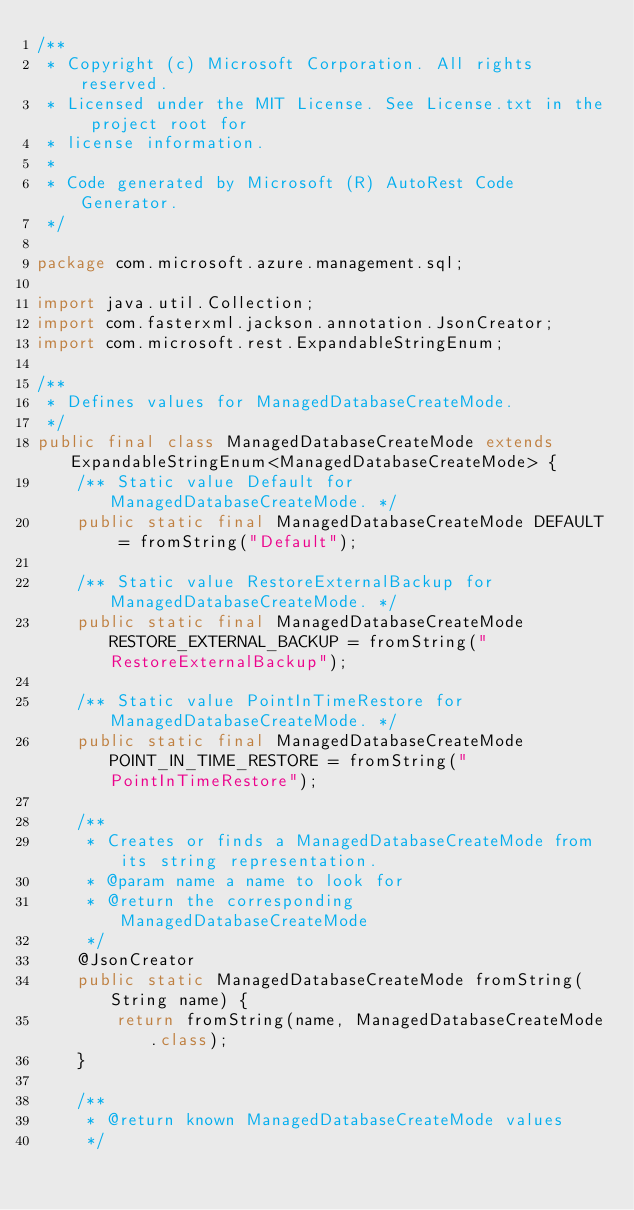Convert code to text. <code><loc_0><loc_0><loc_500><loc_500><_Java_>/**
 * Copyright (c) Microsoft Corporation. All rights reserved.
 * Licensed under the MIT License. See License.txt in the project root for
 * license information.
 *
 * Code generated by Microsoft (R) AutoRest Code Generator.
 */

package com.microsoft.azure.management.sql;

import java.util.Collection;
import com.fasterxml.jackson.annotation.JsonCreator;
import com.microsoft.rest.ExpandableStringEnum;

/**
 * Defines values for ManagedDatabaseCreateMode.
 */
public final class ManagedDatabaseCreateMode extends ExpandableStringEnum<ManagedDatabaseCreateMode> {
    /** Static value Default for ManagedDatabaseCreateMode. */
    public static final ManagedDatabaseCreateMode DEFAULT = fromString("Default");

    /** Static value RestoreExternalBackup for ManagedDatabaseCreateMode. */
    public static final ManagedDatabaseCreateMode RESTORE_EXTERNAL_BACKUP = fromString("RestoreExternalBackup");

    /** Static value PointInTimeRestore for ManagedDatabaseCreateMode. */
    public static final ManagedDatabaseCreateMode POINT_IN_TIME_RESTORE = fromString("PointInTimeRestore");

    /**
     * Creates or finds a ManagedDatabaseCreateMode from its string representation.
     * @param name a name to look for
     * @return the corresponding ManagedDatabaseCreateMode
     */
    @JsonCreator
    public static ManagedDatabaseCreateMode fromString(String name) {
        return fromString(name, ManagedDatabaseCreateMode.class);
    }

    /**
     * @return known ManagedDatabaseCreateMode values
     */</code> 